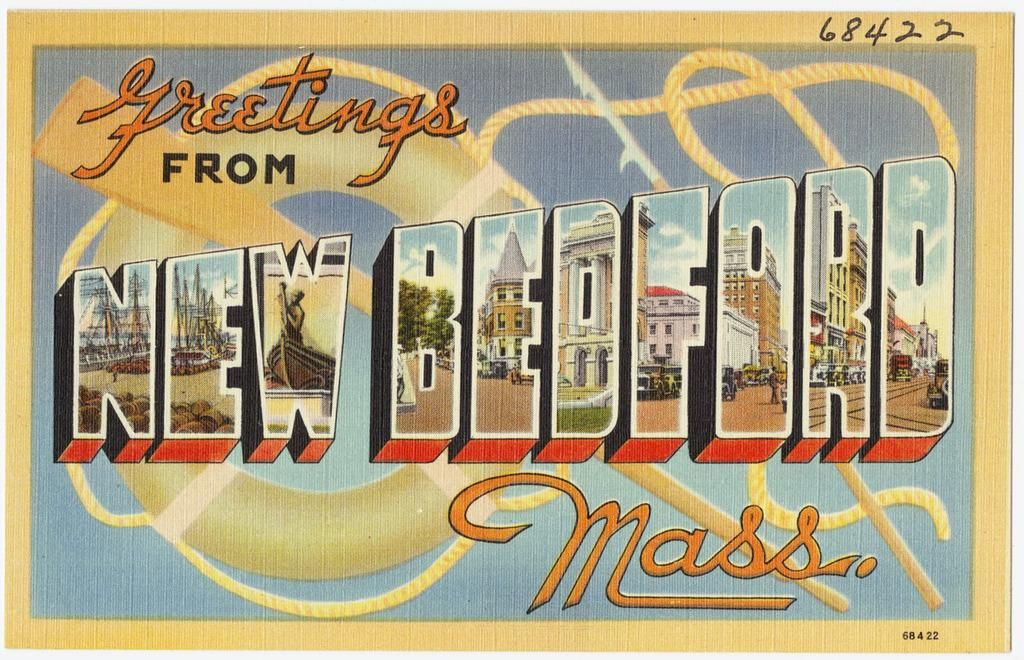What is the main subject of the picture? The main subject of the picture is a cartoon image of a card. What message is written on the card? The words "greetings from new bedford" are written on the card. What type of suit can be seen hanging in the background of the image? There is no suit visible in the image; it only features a cartoon image of a card with the message "greetings from new bedford." 